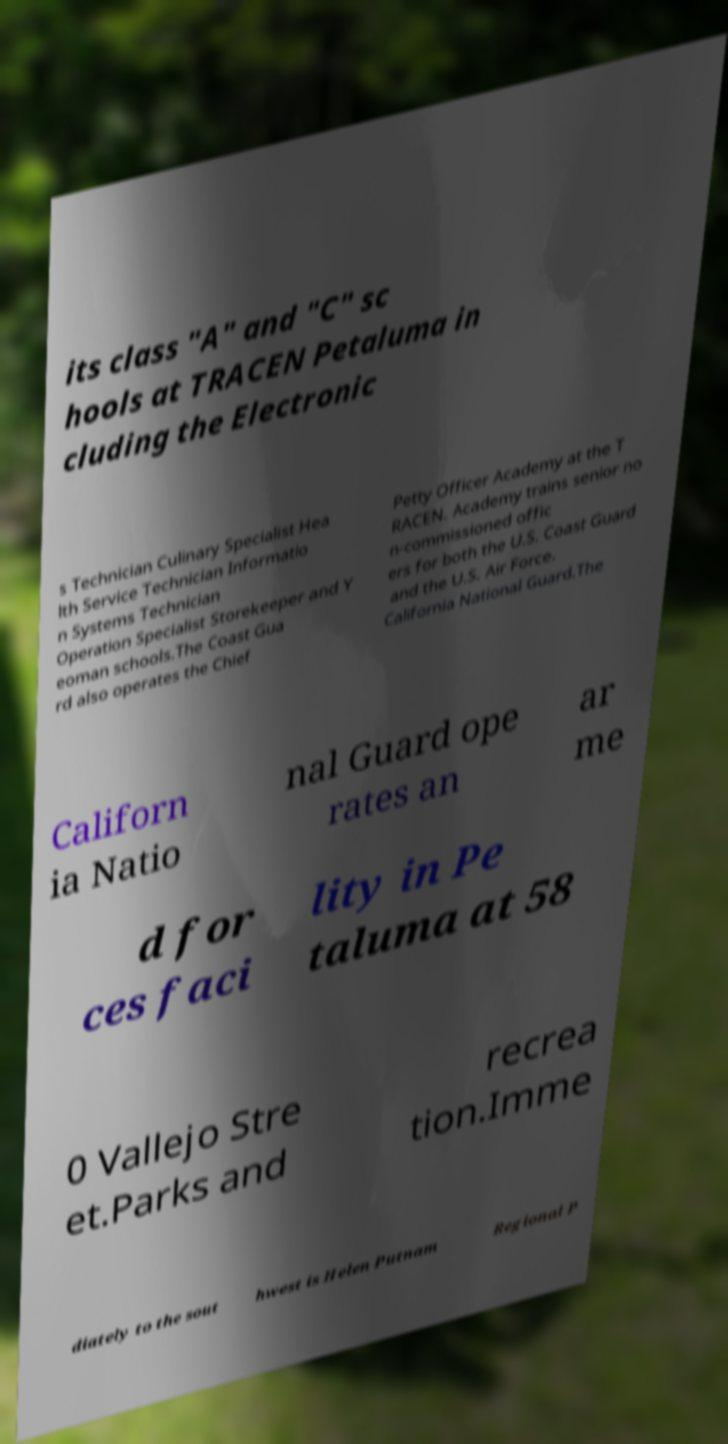Can you read and provide the text displayed in the image?This photo seems to have some interesting text. Can you extract and type it out for me? its class "A" and "C" sc hools at TRACEN Petaluma in cluding the Electronic s Technician Culinary Specialist Hea lth Service Technician Informatio n Systems Technician Operation Specialist Storekeeper and Y eoman schools.The Coast Gua rd also operates the Chief Petty Officer Academy at the T RACEN. Academy trains senior no n-commissioned offic ers for both the U.S. Coast Guard and the U.S. Air Force. California National Guard.The Californ ia Natio nal Guard ope rates an ar me d for ces faci lity in Pe taluma at 58 0 Vallejo Stre et.Parks and recrea tion.Imme diately to the sout hwest is Helen Putnam Regional P 